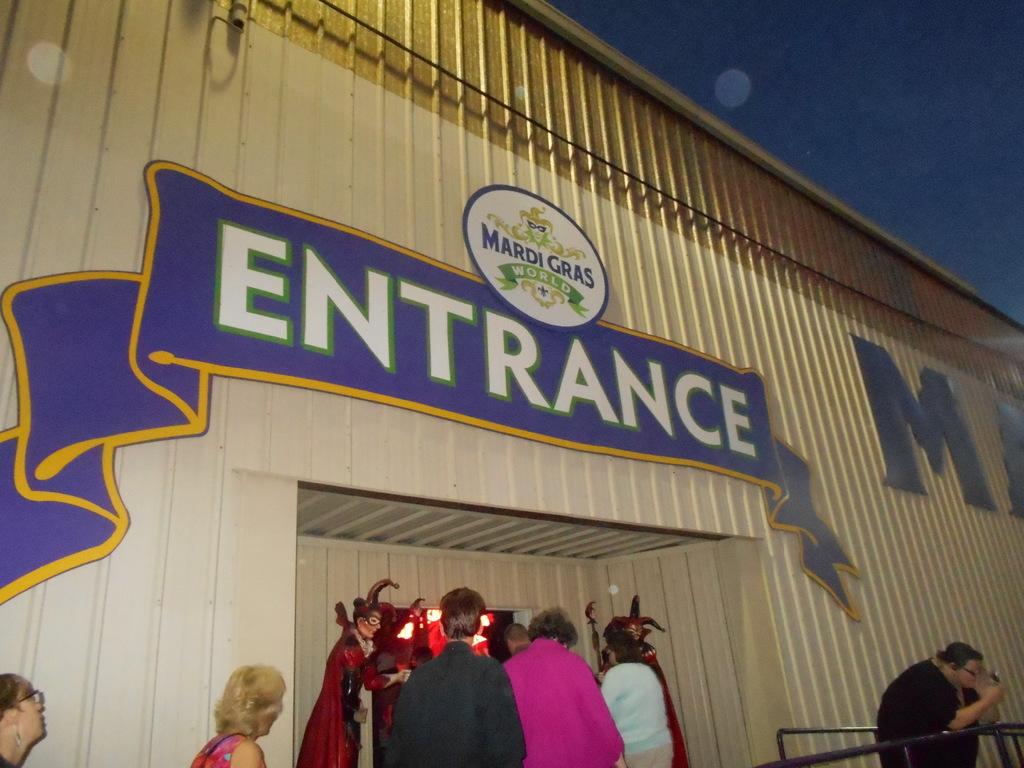What festival is this from?
Provide a short and direct response. Mardi gras. 